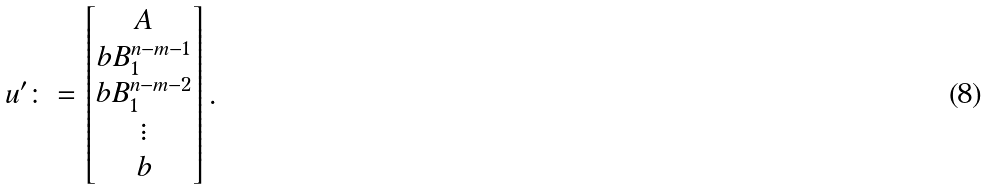<formula> <loc_0><loc_0><loc_500><loc_500>u ^ { \prime } \colon = \begin{bmatrix} A \\ b B _ { 1 } ^ { n - m - 1 } \\ b B _ { 1 } ^ { n - m - 2 } \\ \vdots \\ b \end{bmatrix} .</formula> 